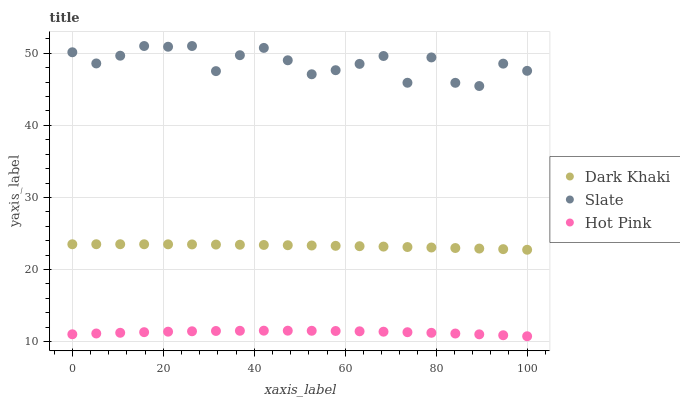Does Hot Pink have the minimum area under the curve?
Answer yes or no. Yes. Does Slate have the maximum area under the curve?
Answer yes or no. Yes. Does Slate have the minimum area under the curve?
Answer yes or no. No. Does Hot Pink have the maximum area under the curve?
Answer yes or no. No. Is Dark Khaki the smoothest?
Answer yes or no. Yes. Is Slate the roughest?
Answer yes or no. Yes. Is Hot Pink the smoothest?
Answer yes or no. No. Is Hot Pink the roughest?
Answer yes or no. No. Does Hot Pink have the lowest value?
Answer yes or no. Yes. Does Slate have the lowest value?
Answer yes or no. No. Does Slate have the highest value?
Answer yes or no. Yes. Does Hot Pink have the highest value?
Answer yes or no. No. Is Hot Pink less than Slate?
Answer yes or no. Yes. Is Dark Khaki greater than Hot Pink?
Answer yes or no. Yes. Does Hot Pink intersect Slate?
Answer yes or no. No. 